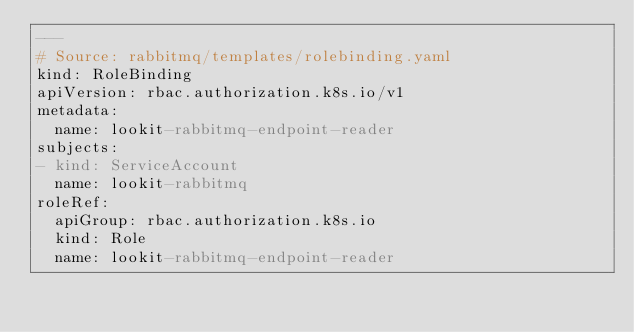<code> <loc_0><loc_0><loc_500><loc_500><_YAML_>---
# Source: rabbitmq/templates/rolebinding.yaml
kind: RoleBinding
apiVersion: rbac.authorization.k8s.io/v1
metadata:
  name: lookit-rabbitmq-endpoint-reader
subjects:
- kind: ServiceAccount
  name: lookit-rabbitmq
roleRef:
  apiGroup: rbac.authorization.k8s.io
  kind: Role
  name: lookit-rabbitmq-endpoint-reader
</code> 